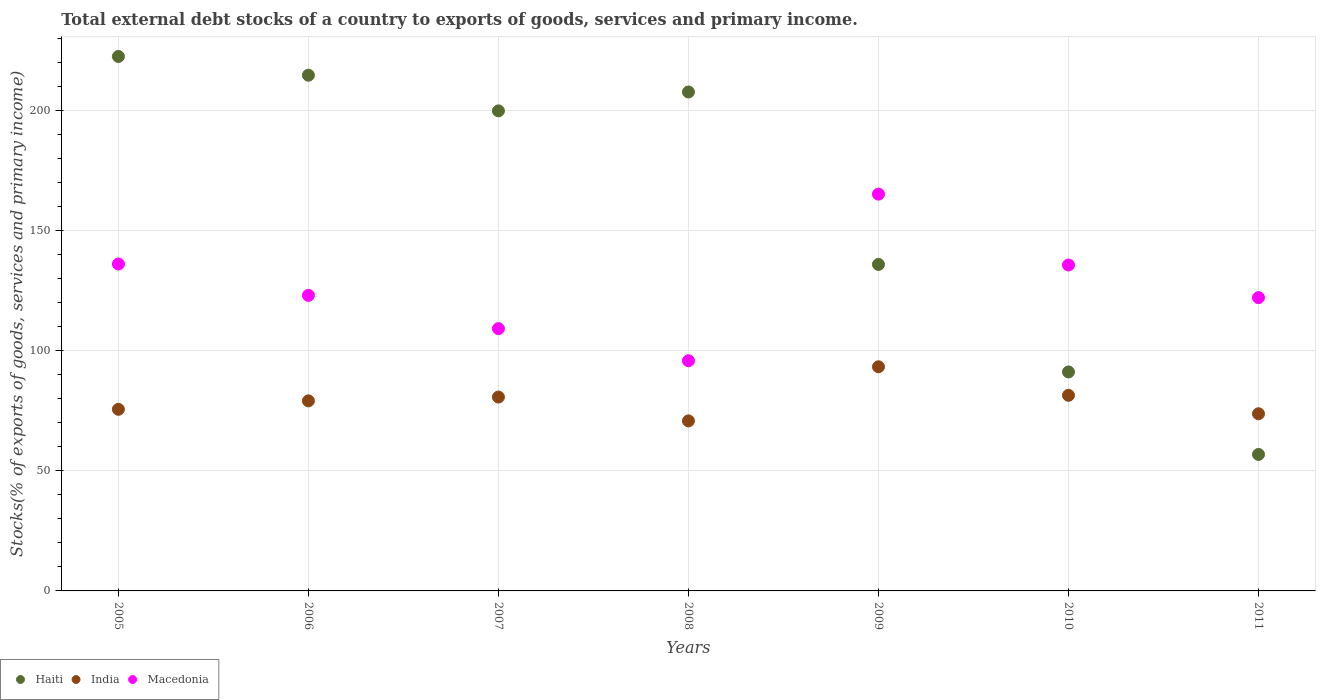What is the total debt stocks in Macedonia in 2007?
Give a very brief answer. 109.24. Across all years, what is the maximum total debt stocks in Haiti?
Ensure brevity in your answer.  222.59. Across all years, what is the minimum total debt stocks in Macedonia?
Ensure brevity in your answer.  95.87. In which year was the total debt stocks in India maximum?
Provide a short and direct response. 2009. What is the total total debt stocks in Haiti in the graph?
Your answer should be compact. 1129.14. What is the difference between the total debt stocks in Macedonia in 2005 and that in 2010?
Your answer should be compact. 0.41. What is the difference between the total debt stocks in India in 2006 and the total debt stocks in Macedonia in 2010?
Your answer should be very brief. -56.58. What is the average total debt stocks in India per year?
Give a very brief answer. 79.28. In the year 2010, what is the difference between the total debt stocks in India and total debt stocks in Macedonia?
Ensure brevity in your answer.  -54.27. In how many years, is the total debt stocks in Macedonia greater than 210 %?
Ensure brevity in your answer.  0. What is the ratio of the total debt stocks in India in 2008 to that in 2010?
Your answer should be compact. 0.87. Is the difference between the total debt stocks in India in 2005 and 2008 greater than the difference between the total debt stocks in Macedonia in 2005 and 2008?
Give a very brief answer. No. What is the difference between the highest and the second highest total debt stocks in India?
Offer a terse response. 11.88. What is the difference between the highest and the lowest total debt stocks in Haiti?
Ensure brevity in your answer.  165.74. In how many years, is the total debt stocks in Macedonia greater than the average total debt stocks in Macedonia taken over all years?
Give a very brief answer. 3. Is the sum of the total debt stocks in Haiti in 2006 and 2010 greater than the maximum total debt stocks in Macedonia across all years?
Provide a succinct answer. Yes. Is it the case that in every year, the sum of the total debt stocks in India and total debt stocks in Haiti  is greater than the total debt stocks in Macedonia?
Make the answer very short. Yes. Is the total debt stocks in Macedonia strictly greater than the total debt stocks in India over the years?
Provide a succinct answer. Yes. Is the total debt stocks in India strictly less than the total debt stocks in Haiti over the years?
Provide a short and direct response. No. Does the graph contain grids?
Your answer should be very brief. Yes. How many legend labels are there?
Your response must be concise. 3. What is the title of the graph?
Give a very brief answer. Total external debt stocks of a country to exports of goods, services and primary income. Does "Czech Republic" appear as one of the legend labels in the graph?
Provide a short and direct response. No. What is the label or title of the X-axis?
Your answer should be compact. Years. What is the label or title of the Y-axis?
Provide a succinct answer. Stocks(% of exports of goods, services and primary income). What is the Stocks(% of exports of goods, services and primary income) in Haiti in 2005?
Provide a succinct answer. 222.59. What is the Stocks(% of exports of goods, services and primary income) in India in 2005?
Offer a very short reply. 75.64. What is the Stocks(% of exports of goods, services and primary income) of Macedonia in 2005?
Offer a terse response. 136.15. What is the Stocks(% of exports of goods, services and primary income) of Haiti in 2006?
Keep it short and to the point. 214.79. What is the Stocks(% of exports of goods, services and primary income) of India in 2006?
Your answer should be very brief. 79.16. What is the Stocks(% of exports of goods, services and primary income) in Macedonia in 2006?
Provide a short and direct response. 123.09. What is the Stocks(% of exports of goods, services and primary income) in Haiti in 2007?
Your answer should be compact. 199.93. What is the Stocks(% of exports of goods, services and primary income) in India in 2007?
Make the answer very short. 80.74. What is the Stocks(% of exports of goods, services and primary income) in Macedonia in 2007?
Provide a short and direct response. 109.24. What is the Stocks(% of exports of goods, services and primary income) in Haiti in 2008?
Ensure brevity in your answer.  207.8. What is the Stocks(% of exports of goods, services and primary income) in India in 2008?
Provide a succinct answer. 70.81. What is the Stocks(% of exports of goods, services and primary income) in Macedonia in 2008?
Keep it short and to the point. 95.87. What is the Stocks(% of exports of goods, services and primary income) in Haiti in 2009?
Offer a terse response. 135.98. What is the Stocks(% of exports of goods, services and primary income) of India in 2009?
Your response must be concise. 93.35. What is the Stocks(% of exports of goods, services and primary income) of Macedonia in 2009?
Your answer should be very brief. 165.25. What is the Stocks(% of exports of goods, services and primary income) in Haiti in 2010?
Offer a terse response. 91.2. What is the Stocks(% of exports of goods, services and primary income) in India in 2010?
Keep it short and to the point. 81.47. What is the Stocks(% of exports of goods, services and primary income) of Macedonia in 2010?
Ensure brevity in your answer.  135.74. What is the Stocks(% of exports of goods, services and primary income) of Haiti in 2011?
Your answer should be very brief. 56.85. What is the Stocks(% of exports of goods, services and primary income) in India in 2011?
Keep it short and to the point. 73.79. What is the Stocks(% of exports of goods, services and primary income) in Macedonia in 2011?
Provide a succinct answer. 122.16. Across all years, what is the maximum Stocks(% of exports of goods, services and primary income) of Haiti?
Your response must be concise. 222.59. Across all years, what is the maximum Stocks(% of exports of goods, services and primary income) of India?
Offer a terse response. 93.35. Across all years, what is the maximum Stocks(% of exports of goods, services and primary income) of Macedonia?
Keep it short and to the point. 165.25. Across all years, what is the minimum Stocks(% of exports of goods, services and primary income) of Haiti?
Provide a short and direct response. 56.85. Across all years, what is the minimum Stocks(% of exports of goods, services and primary income) in India?
Provide a short and direct response. 70.81. Across all years, what is the minimum Stocks(% of exports of goods, services and primary income) in Macedonia?
Make the answer very short. 95.87. What is the total Stocks(% of exports of goods, services and primary income) of Haiti in the graph?
Ensure brevity in your answer.  1129.14. What is the total Stocks(% of exports of goods, services and primary income) in India in the graph?
Provide a succinct answer. 554.96. What is the total Stocks(% of exports of goods, services and primary income) in Macedonia in the graph?
Make the answer very short. 887.51. What is the difference between the Stocks(% of exports of goods, services and primary income) in Haiti in 2005 and that in 2006?
Give a very brief answer. 7.8. What is the difference between the Stocks(% of exports of goods, services and primary income) in India in 2005 and that in 2006?
Offer a terse response. -3.52. What is the difference between the Stocks(% of exports of goods, services and primary income) in Macedonia in 2005 and that in 2006?
Ensure brevity in your answer.  13.06. What is the difference between the Stocks(% of exports of goods, services and primary income) of Haiti in 2005 and that in 2007?
Give a very brief answer. 22.66. What is the difference between the Stocks(% of exports of goods, services and primary income) of India in 2005 and that in 2007?
Your answer should be compact. -5.1. What is the difference between the Stocks(% of exports of goods, services and primary income) in Macedonia in 2005 and that in 2007?
Make the answer very short. 26.91. What is the difference between the Stocks(% of exports of goods, services and primary income) of Haiti in 2005 and that in 2008?
Your answer should be compact. 14.79. What is the difference between the Stocks(% of exports of goods, services and primary income) in India in 2005 and that in 2008?
Provide a succinct answer. 4.82. What is the difference between the Stocks(% of exports of goods, services and primary income) in Macedonia in 2005 and that in 2008?
Make the answer very short. 40.28. What is the difference between the Stocks(% of exports of goods, services and primary income) in Haiti in 2005 and that in 2009?
Provide a short and direct response. 86.61. What is the difference between the Stocks(% of exports of goods, services and primary income) in India in 2005 and that in 2009?
Ensure brevity in your answer.  -17.71. What is the difference between the Stocks(% of exports of goods, services and primary income) in Macedonia in 2005 and that in 2009?
Make the answer very short. -29.1. What is the difference between the Stocks(% of exports of goods, services and primary income) in Haiti in 2005 and that in 2010?
Provide a succinct answer. 131.39. What is the difference between the Stocks(% of exports of goods, services and primary income) of India in 2005 and that in 2010?
Offer a terse response. -5.83. What is the difference between the Stocks(% of exports of goods, services and primary income) in Macedonia in 2005 and that in 2010?
Offer a terse response. 0.41. What is the difference between the Stocks(% of exports of goods, services and primary income) of Haiti in 2005 and that in 2011?
Keep it short and to the point. 165.74. What is the difference between the Stocks(% of exports of goods, services and primary income) of India in 2005 and that in 2011?
Make the answer very short. 1.85. What is the difference between the Stocks(% of exports of goods, services and primary income) in Macedonia in 2005 and that in 2011?
Offer a terse response. 14. What is the difference between the Stocks(% of exports of goods, services and primary income) in Haiti in 2006 and that in 2007?
Your answer should be very brief. 14.85. What is the difference between the Stocks(% of exports of goods, services and primary income) of India in 2006 and that in 2007?
Give a very brief answer. -1.58. What is the difference between the Stocks(% of exports of goods, services and primary income) of Macedonia in 2006 and that in 2007?
Your response must be concise. 13.85. What is the difference between the Stocks(% of exports of goods, services and primary income) of Haiti in 2006 and that in 2008?
Provide a succinct answer. 6.98. What is the difference between the Stocks(% of exports of goods, services and primary income) of India in 2006 and that in 2008?
Offer a terse response. 8.35. What is the difference between the Stocks(% of exports of goods, services and primary income) in Macedonia in 2006 and that in 2008?
Keep it short and to the point. 27.22. What is the difference between the Stocks(% of exports of goods, services and primary income) in Haiti in 2006 and that in 2009?
Offer a terse response. 78.81. What is the difference between the Stocks(% of exports of goods, services and primary income) of India in 2006 and that in 2009?
Give a very brief answer. -14.18. What is the difference between the Stocks(% of exports of goods, services and primary income) in Macedonia in 2006 and that in 2009?
Keep it short and to the point. -42.16. What is the difference between the Stocks(% of exports of goods, services and primary income) of Haiti in 2006 and that in 2010?
Offer a very short reply. 123.58. What is the difference between the Stocks(% of exports of goods, services and primary income) in India in 2006 and that in 2010?
Provide a succinct answer. -2.3. What is the difference between the Stocks(% of exports of goods, services and primary income) in Macedonia in 2006 and that in 2010?
Offer a very short reply. -12.65. What is the difference between the Stocks(% of exports of goods, services and primary income) of Haiti in 2006 and that in 2011?
Your response must be concise. 157.94. What is the difference between the Stocks(% of exports of goods, services and primary income) of India in 2006 and that in 2011?
Your response must be concise. 5.38. What is the difference between the Stocks(% of exports of goods, services and primary income) of Macedonia in 2006 and that in 2011?
Make the answer very short. 0.93. What is the difference between the Stocks(% of exports of goods, services and primary income) in Haiti in 2007 and that in 2008?
Your answer should be compact. -7.87. What is the difference between the Stocks(% of exports of goods, services and primary income) in India in 2007 and that in 2008?
Your response must be concise. 9.93. What is the difference between the Stocks(% of exports of goods, services and primary income) in Macedonia in 2007 and that in 2008?
Provide a short and direct response. 13.37. What is the difference between the Stocks(% of exports of goods, services and primary income) of Haiti in 2007 and that in 2009?
Provide a succinct answer. 63.96. What is the difference between the Stocks(% of exports of goods, services and primary income) of India in 2007 and that in 2009?
Offer a terse response. -12.61. What is the difference between the Stocks(% of exports of goods, services and primary income) in Macedonia in 2007 and that in 2009?
Provide a short and direct response. -56.01. What is the difference between the Stocks(% of exports of goods, services and primary income) of Haiti in 2007 and that in 2010?
Your answer should be very brief. 108.73. What is the difference between the Stocks(% of exports of goods, services and primary income) of India in 2007 and that in 2010?
Offer a very short reply. -0.73. What is the difference between the Stocks(% of exports of goods, services and primary income) of Macedonia in 2007 and that in 2010?
Provide a short and direct response. -26.5. What is the difference between the Stocks(% of exports of goods, services and primary income) in Haiti in 2007 and that in 2011?
Your answer should be very brief. 143.09. What is the difference between the Stocks(% of exports of goods, services and primary income) in India in 2007 and that in 2011?
Your response must be concise. 6.96. What is the difference between the Stocks(% of exports of goods, services and primary income) in Macedonia in 2007 and that in 2011?
Keep it short and to the point. -12.92. What is the difference between the Stocks(% of exports of goods, services and primary income) in Haiti in 2008 and that in 2009?
Keep it short and to the point. 71.83. What is the difference between the Stocks(% of exports of goods, services and primary income) in India in 2008 and that in 2009?
Your answer should be compact. -22.53. What is the difference between the Stocks(% of exports of goods, services and primary income) in Macedonia in 2008 and that in 2009?
Ensure brevity in your answer.  -69.38. What is the difference between the Stocks(% of exports of goods, services and primary income) in Haiti in 2008 and that in 2010?
Your answer should be compact. 116.6. What is the difference between the Stocks(% of exports of goods, services and primary income) of India in 2008 and that in 2010?
Your answer should be very brief. -10.65. What is the difference between the Stocks(% of exports of goods, services and primary income) of Macedonia in 2008 and that in 2010?
Offer a terse response. -39.87. What is the difference between the Stocks(% of exports of goods, services and primary income) in Haiti in 2008 and that in 2011?
Make the answer very short. 150.96. What is the difference between the Stocks(% of exports of goods, services and primary income) of India in 2008 and that in 2011?
Ensure brevity in your answer.  -2.97. What is the difference between the Stocks(% of exports of goods, services and primary income) of Macedonia in 2008 and that in 2011?
Provide a short and direct response. -26.28. What is the difference between the Stocks(% of exports of goods, services and primary income) of Haiti in 2009 and that in 2010?
Provide a short and direct response. 44.77. What is the difference between the Stocks(% of exports of goods, services and primary income) in India in 2009 and that in 2010?
Your response must be concise. 11.88. What is the difference between the Stocks(% of exports of goods, services and primary income) of Macedonia in 2009 and that in 2010?
Ensure brevity in your answer.  29.51. What is the difference between the Stocks(% of exports of goods, services and primary income) in Haiti in 2009 and that in 2011?
Your answer should be very brief. 79.13. What is the difference between the Stocks(% of exports of goods, services and primary income) of India in 2009 and that in 2011?
Give a very brief answer. 19.56. What is the difference between the Stocks(% of exports of goods, services and primary income) of Macedonia in 2009 and that in 2011?
Keep it short and to the point. 43.1. What is the difference between the Stocks(% of exports of goods, services and primary income) of Haiti in 2010 and that in 2011?
Ensure brevity in your answer.  34.35. What is the difference between the Stocks(% of exports of goods, services and primary income) of India in 2010 and that in 2011?
Your answer should be compact. 7.68. What is the difference between the Stocks(% of exports of goods, services and primary income) in Macedonia in 2010 and that in 2011?
Make the answer very short. 13.58. What is the difference between the Stocks(% of exports of goods, services and primary income) of Haiti in 2005 and the Stocks(% of exports of goods, services and primary income) of India in 2006?
Ensure brevity in your answer.  143.43. What is the difference between the Stocks(% of exports of goods, services and primary income) in Haiti in 2005 and the Stocks(% of exports of goods, services and primary income) in Macedonia in 2006?
Keep it short and to the point. 99.5. What is the difference between the Stocks(% of exports of goods, services and primary income) in India in 2005 and the Stocks(% of exports of goods, services and primary income) in Macedonia in 2006?
Keep it short and to the point. -47.45. What is the difference between the Stocks(% of exports of goods, services and primary income) of Haiti in 2005 and the Stocks(% of exports of goods, services and primary income) of India in 2007?
Offer a terse response. 141.85. What is the difference between the Stocks(% of exports of goods, services and primary income) of Haiti in 2005 and the Stocks(% of exports of goods, services and primary income) of Macedonia in 2007?
Give a very brief answer. 113.35. What is the difference between the Stocks(% of exports of goods, services and primary income) in India in 2005 and the Stocks(% of exports of goods, services and primary income) in Macedonia in 2007?
Provide a short and direct response. -33.6. What is the difference between the Stocks(% of exports of goods, services and primary income) of Haiti in 2005 and the Stocks(% of exports of goods, services and primary income) of India in 2008?
Keep it short and to the point. 151.78. What is the difference between the Stocks(% of exports of goods, services and primary income) of Haiti in 2005 and the Stocks(% of exports of goods, services and primary income) of Macedonia in 2008?
Ensure brevity in your answer.  126.72. What is the difference between the Stocks(% of exports of goods, services and primary income) in India in 2005 and the Stocks(% of exports of goods, services and primary income) in Macedonia in 2008?
Ensure brevity in your answer.  -20.24. What is the difference between the Stocks(% of exports of goods, services and primary income) in Haiti in 2005 and the Stocks(% of exports of goods, services and primary income) in India in 2009?
Give a very brief answer. 129.24. What is the difference between the Stocks(% of exports of goods, services and primary income) of Haiti in 2005 and the Stocks(% of exports of goods, services and primary income) of Macedonia in 2009?
Your answer should be very brief. 57.34. What is the difference between the Stocks(% of exports of goods, services and primary income) of India in 2005 and the Stocks(% of exports of goods, services and primary income) of Macedonia in 2009?
Offer a terse response. -89.62. What is the difference between the Stocks(% of exports of goods, services and primary income) in Haiti in 2005 and the Stocks(% of exports of goods, services and primary income) in India in 2010?
Keep it short and to the point. 141.12. What is the difference between the Stocks(% of exports of goods, services and primary income) in Haiti in 2005 and the Stocks(% of exports of goods, services and primary income) in Macedonia in 2010?
Offer a terse response. 86.85. What is the difference between the Stocks(% of exports of goods, services and primary income) of India in 2005 and the Stocks(% of exports of goods, services and primary income) of Macedonia in 2010?
Provide a succinct answer. -60.1. What is the difference between the Stocks(% of exports of goods, services and primary income) of Haiti in 2005 and the Stocks(% of exports of goods, services and primary income) of India in 2011?
Provide a succinct answer. 148.81. What is the difference between the Stocks(% of exports of goods, services and primary income) in Haiti in 2005 and the Stocks(% of exports of goods, services and primary income) in Macedonia in 2011?
Your answer should be very brief. 100.43. What is the difference between the Stocks(% of exports of goods, services and primary income) in India in 2005 and the Stocks(% of exports of goods, services and primary income) in Macedonia in 2011?
Your answer should be compact. -46.52. What is the difference between the Stocks(% of exports of goods, services and primary income) in Haiti in 2006 and the Stocks(% of exports of goods, services and primary income) in India in 2007?
Your answer should be compact. 134.05. What is the difference between the Stocks(% of exports of goods, services and primary income) in Haiti in 2006 and the Stocks(% of exports of goods, services and primary income) in Macedonia in 2007?
Your answer should be compact. 105.55. What is the difference between the Stocks(% of exports of goods, services and primary income) in India in 2006 and the Stocks(% of exports of goods, services and primary income) in Macedonia in 2007?
Your answer should be very brief. -30.08. What is the difference between the Stocks(% of exports of goods, services and primary income) in Haiti in 2006 and the Stocks(% of exports of goods, services and primary income) in India in 2008?
Keep it short and to the point. 143.97. What is the difference between the Stocks(% of exports of goods, services and primary income) of Haiti in 2006 and the Stocks(% of exports of goods, services and primary income) of Macedonia in 2008?
Provide a succinct answer. 118.91. What is the difference between the Stocks(% of exports of goods, services and primary income) of India in 2006 and the Stocks(% of exports of goods, services and primary income) of Macedonia in 2008?
Keep it short and to the point. -16.71. What is the difference between the Stocks(% of exports of goods, services and primary income) in Haiti in 2006 and the Stocks(% of exports of goods, services and primary income) in India in 2009?
Provide a short and direct response. 121.44. What is the difference between the Stocks(% of exports of goods, services and primary income) in Haiti in 2006 and the Stocks(% of exports of goods, services and primary income) in Macedonia in 2009?
Give a very brief answer. 49.53. What is the difference between the Stocks(% of exports of goods, services and primary income) in India in 2006 and the Stocks(% of exports of goods, services and primary income) in Macedonia in 2009?
Ensure brevity in your answer.  -86.09. What is the difference between the Stocks(% of exports of goods, services and primary income) in Haiti in 2006 and the Stocks(% of exports of goods, services and primary income) in India in 2010?
Your answer should be compact. 133.32. What is the difference between the Stocks(% of exports of goods, services and primary income) of Haiti in 2006 and the Stocks(% of exports of goods, services and primary income) of Macedonia in 2010?
Provide a short and direct response. 79.04. What is the difference between the Stocks(% of exports of goods, services and primary income) in India in 2006 and the Stocks(% of exports of goods, services and primary income) in Macedonia in 2010?
Make the answer very short. -56.58. What is the difference between the Stocks(% of exports of goods, services and primary income) of Haiti in 2006 and the Stocks(% of exports of goods, services and primary income) of India in 2011?
Your answer should be very brief. 141. What is the difference between the Stocks(% of exports of goods, services and primary income) of Haiti in 2006 and the Stocks(% of exports of goods, services and primary income) of Macedonia in 2011?
Your response must be concise. 92.63. What is the difference between the Stocks(% of exports of goods, services and primary income) in India in 2006 and the Stocks(% of exports of goods, services and primary income) in Macedonia in 2011?
Keep it short and to the point. -42.99. What is the difference between the Stocks(% of exports of goods, services and primary income) of Haiti in 2007 and the Stocks(% of exports of goods, services and primary income) of India in 2008?
Offer a terse response. 129.12. What is the difference between the Stocks(% of exports of goods, services and primary income) in Haiti in 2007 and the Stocks(% of exports of goods, services and primary income) in Macedonia in 2008?
Ensure brevity in your answer.  104.06. What is the difference between the Stocks(% of exports of goods, services and primary income) in India in 2007 and the Stocks(% of exports of goods, services and primary income) in Macedonia in 2008?
Your response must be concise. -15.13. What is the difference between the Stocks(% of exports of goods, services and primary income) of Haiti in 2007 and the Stocks(% of exports of goods, services and primary income) of India in 2009?
Provide a short and direct response. 106.59. What is the difference between the Stocks(% of exports of goods, services and primary income) of Haiti in 2007 and the Stocks(% of exports of goods, services and primary income) of Macedonia in 2009?
Provide a short and direct response. 34.68. What is the difference between the Stocks(% of exports of goods, services and primary income) of India in 2007 and the Stocks(% of exports of goods, services and primary income) of Macedonia in 2009?
Offer a very short reply. -84.51. What is the difference between the Stocks(% of exports of goods, services and primary income) in Haiti in 2007 and the Stocks(% of exports of goods, services and primary income) in India in 2010?
Make the answer very short. 118.47. What is the difference between the Stocks(% of exports of goods, services and primary income) in Haiti in 2007 and the Stocks(% of exports of goods, services and primary income) in Macedonia in 2010?
Ensure brevity in your answer.  64.19. What is the difference between the Stocks(% of exports of goods, services and primary income) in India in 2007 and the Stocks(% of exports of goods, services and primary income) in Macedonia in 2010?
Your answer should be very brief. -55. What is the difference between the Stocks(% of exports of goods, services and primary income) in Haiti in 2007 and the Stocks(% of exports of goods, services and primary income) in India in 2011?
Keep it short and to the point. 126.15. What is the difference between the Stocks(% of exports of goods, services and primary income) in Haiti in 2007 and the Stocks(% of exports of goods, services and primary income) in Macedonia in 2011?
Your answer should be compact. 77.78. What is the difference between the Stocks(% of exports of goods, services and primary income) of India in 2007 and the Stocks(% of exports of goods, services and primary income) of Macedonia in 2011?
Your answer should be compact. -41.42. What is the difference between the Stocks(% of exports of goods, services and primary income) of Haiti in 2008 and the Stocks(% of exports of goods, services and primary income) of India in 2009?
Your answer should be compact. 114.46. What is the difference between the Stocks(% of exports of goods, services and primary income) in Haiti in 2008 and the Stocks(% of exports of goods, services and primary income) in Macedonia in 2009?
Your answer should be very brief. 42.55. What is the difference between the Stocks(% of exports of goods, services and primary income) of India in 2008 and the Stocks(% of exports of goods, services and primary income) of Macedonia in 2009?
Provide a succinct answer. -94.44. What is the difference between the Stocks(% of exports of goods, services and primary income) in Haiti in 2008 and the Stocks(% of exports of goods, services and primary income) in India in 2010?
Your answer should be very brief. 126.34. What is the difference between the Stocks(% of exports of goods, services and primary income) in Haiti in 2008 and the Stocks(% of exports of goods, services and primary income) in Macedonia in 2010?
Provide a succinct answer. 72.06. What is the difference between the Stocks(% of exports of goods, services and primary income) in India in 2008 and the Stocks(% of exports of goods, services and primary income) in Macedonia in 2010?
Your answer should be very brief. -64.93. What is the difference between the Stocks(% of exports of goods, services and primary income) in Haiti in 2008 and the Stocks(% of exports of goods, services and primary income) in India in 2011?
Offer a very short reply. 134.02. What is the difference between the Stocks(% of exports of goods, services and primary income) of Haiti in 2008 and the Stocks(% of exports of goods, services and primary income) of Macedonia in 2011?
Your response must be concise. 85.65. What is the difference between the Stocks(% of exports of goods, services and primary income) of India in 2008 and the Stocks(% of exports of goods, services and primary income) of Macedonia in 2011?
Keep it short and to the point. -51.34. What is the difference between the Stocks(% of exports of goods, services and primary income) in Haiti in 2009 and the Stocks(% of exports of goods, services and primary income) in India in 2010?
Make the answer very short. 54.51. What is the difference between the Stocks(% of exports of goods, services and primary income) of Haiti in 2009 and the Stocks(% of exports of goods, services and primary income) of Macedonia in 2010?
Provide a succinct answer. 0.23. What is the difference between the Stocks(% of exports of goods, services and primary income) of India in 2009 and the Stocks(% of exports of goods, services and primary income) of Macedonia in 2010?
Give a very brief answer. -42.39. What is the difference between the Stocks(% of exports of goods, services and primary income) in Haiti in 2009 and the Stocks(% of exports of goods, services and primary income) in India in 2011?
Offer a terse response. 62.19. What is the difference between the Stocks(% of exports of goods, services and primary income) of Haiti in 2009 and the Stocks(% of exports of goods, services and primary income) of Macedonia in 2011?
Give a very brief answer. 13.82. What is the difference between the Stocks(% of exports of goods, services and primary income) of India in 2009 and the Stocks(% of exports of goods, services and primary income) of Macedonia in 2011?
Your answer should be very brief. -28.81. What is the difference between the Stocks(% of exports of goods, services and primary income) in Haiti in 2010 and the Stocks(% of exports of goods, services and primary income) in India in 2011?
Offer a very short reply. 17.42. What is the difference between the Stocks(% of exports of goods, services and primary income) of Haiti in 2010 and the Stocks(% of exports of goods, services and primary income) of Macedonia in 2011?
Offer a very short reply. -30.95. What is the difference between the Stocks(% of exports of goods, services and primary income) of India in 2010 and the Stocks(% of exports of goods, services and primary income) of Macedonia in 2011?
Keep it short and to the point. -40.69. What is the average Stocks(% of exports of goods, services and primary income) in Haiti per year?
Provide a succinct answer. 161.31. What is the average Stocks(% of exports of goods, services and primary income) of India per year?
Offer a terse response. 79.28. What is the average Stocks(% of exports of goods, services and primary income) of Macedonia per year?
Provide a succinct answer. 126.79. In the year 2005, what is the difference between the Stocks(% of exports of goods, services and primary income) in Haiti and Stocks(% of exports of goods, services and primary income) in India?
Make the answer very short. 146.95. In the year 2005, what is the difference between the Stocks(% of exports of goods, services and primary income) in Haiti and Stocks(% of exports of goods, services and primary income) in Macedonia?
Provide a short and direct response. 86.44. In the year 2005, what is the difference between the Stocks(% of exports of goods, services and primary income) in India and Stocks(% of exports of goods, services and primary income) in Macedonia?
Provide a succinct answer. -60.51. In the year 2006, what is the difference between the Stocks(% of exports of goods, services and primary income) in Haiti and Stocks(% of exports of goods, services and primary income) in India?
Ensure brevity in your answer.  135.62. In the year 2006, what is the difference between the Stocks(% of exports of goods, services and primary income) of Haiti and Stocks(% of exports of goods, services and primary income) of Macedonia?
Make the answer very short. 91.69. In the year 2006, what is the difference between the Stocks(% of exports of goods, services and primary income) in India and Stocks(% of exports of goods, services and primary income) in Macedonia?
Make the answer very short. -43.93. In the year 2007, what is the difference between the Stocks(% of exports of goods, services and primary income) of Haiti and Stocks(% of exports of goods, services and primary income) of India?
Your answer should be very brief. 119.19. In the year 2007, what is the difference between the Stocks(% of exports of goods, services and primary income) in Haiti and Stocks(% of exports of goods, services and primary income) in Macedonia?
Ensure brevity in your answer.  90.69. In the year 2007, what is the difference between the Stocks(% of exports of goods, services and primary income) in India and Stocks(% of exports of goods, services and primary income) in Macedonia?
Provide a short and direct response. -28.5. In the year 2008, what is the difference between the Stocks(% of exports of goods, services and primary income) of Haiti and Stocks(% of exports of goods, services and primary income) of India?
Give a very brief answer. 136.99. In the year 2008, what is the difference between the Stocks(% of exports of goods, services and primary income) of Haiti and Stocks(% of exports of goods, services and primary income) of Macedonia?
Provide a succinct answer. 111.93. In the year 2008, what is the difference between the Stocks(% of exports of goods, services and primary income) of India and Stocks(% of exports of goods, services and primary income) of Macedonia?
Provide a succinct answer. -25.06. In the year 2009, what is the difference between the Stocks(% of exports of goods, services and primary income) in Haiti and Stocks(% of exports of goods, services and primary income) in India?
Your answer should be compact. 42.63. In the year 2009, what is the difference between the Stocks(% of exports of goods, services and primary income) in Haiti and Stocks(% of exports of goods, services and primary income) in Macedonia?
Your answer should be compact. -29.28. In the year 2009, what is the difference between the Stocks(% of exports of goods, services and primary income) of India and Stocks(% of exports of goods, services and primary income) of Macedonia?
Your answer should be very brief. -71.91. In the year 2010, what is the difference between the Stocks(% of exports of goods, services and primary income) of Haiti and Stocks(% of exports of goods, services and primary income) of India?
Make the answer very short. 9.74. In the year 2010, what is the difference between the Stocks(% of exports of goods, services and primary income) in Haiti and Stocks(% of exports of goods, services and primary income) in Macedonia?
Provide a succinct answer. -44.54. In the year 2010, what is the difference between the Stocks(% of exports of goods, services and primary income) of India and Stocks(% of exports of goods, services and primary income) of Macedonia?
Your answer should be compact. -54.27. In the year 2011, what is the difference between the Stocks(% of exports of goods, services and primary income) of Haiti and Stocks(% of exports of goods, services and primary income) of India?
Offer a terse response. -16.94. In the year 2011, what is the difference between the Stocks(% of exports of goods, services and primary income) of Haiti and Stocks(% of exports of goods, services and primary income) of Macedonia?
Keep it short and to the point. -65.31. In the year 2011, what is the difference between the Stocks(% of exports of goods, services and primary income) in India and Stocks(% of exports of goods, services and primary income) in Macedonia?
Your answer should be compact. -48.37. What is the ratio of the Stocks(% of exports of goods, services and primary income) in Haiti in 2005 to that in 2006?
Give a very brief answer. 1.04. What is the ratio of the Stocks(% of exports of goods, services and primary income) of India in 2005 to that in 2006?
Ensure brevity in your answer.  0.96. What is the ratio of the Stocks(% of exports of goods, services and primary income) in Macedonia in 2005 to that in 2006?
Ensure brevity in your answer.  1.11. What is the ratio of the Stocks(% of exports of goods, services and primary income) of Haiti in 2005 to that in 2007?
Make the answer very short. 1.11. What is the ratio of the Stocks(% of exports of goods, services and primary income) of India in 2005 to that in 2007?
Give a very brief answer. 0.94. What is the ratio of the Stocks(% of exports of goods, services and primary income) of Macedonia in 2005 to that in 2007?
Your answer should be very brief. 1.25. What is the ratio of the Stocks(% of exports of goods, services and primary income) in Haiti in 2005 to that in 2008?
Provide a short and direct response. 1.07. What is the ratio of the Stocks(% of exports of goods, services and primary income) in India in 2005 to that in 2008?
Keep it short and to the point. 1.07. What is the ratio of the Stocks(% of exports of goods, services and primary income) in Macedonia in 2005 to that in 2008?
Provide a succinct answer. 1.42. What is the ratio of the Stocks(% of exports of goods, services and primary income) of Haiti in 2005 to that in 2009?
Ensure brevity in your answer.  1.64. What is the ratio of the Stocks(% of exports of goods, services and primary income) in India in 2005 to that in 2009?
Your answer should be very brief. 0.81. What is the ratio of the Stocks(% of exports of goods, services and primary income) in Macedonia in 2005 to that in 2009?
Your answer should be very brief. 0.82. What is the ratio of the Stocks(% of exports of goods, services and primary income) of Haiti in 2005 to that in 2010?
Keep it short and to the point. 2.44. What is the ratio of the Stocks(% of exports of goods, services and primary income) of India in 2005 to that in 2010?
Give a very brief answer. 0.93. What is the ratio of the Stocks(% of exports of goods, services and primary income) of Haiti in 2005 to that in 2011?
Make the answer very short. 3.92. What is the ratio of the Stocks(% of exports of goods, services and primary income) in India in 2005 to that in 2011?
Provide a succinct answer. 1.03. What is the ratio of the Stocks(% of exports of goods, services and primary income) in Macedonia in 2005 to that in 2011?
Provide a succinct answer. 1.11. What is the ratio of the Stocks(% of exports of goods, services and primary income) in Haiti in 2006 to that in 2007?
Offer a terse response. 1.07. What is the ratio of the Stocks(% of exports of goods, services and primary income) in India in 2006 to that in 2007?
Provide a succinct answer. 0.98. What is the ratio of the Stocks(% of exports of goods, services and primary income) of Macedonia in 2006 to that in 2007?
Provide a short and direct response. 1.13. What is the ratio of the Stocks(% of exports of goods, services and primary income) of Haiti in 2006 to that in 2008?
Offer a very short reply. 1.03. What is the ratio of the Stocks(% of exports of goods, services and primary income) in India in 2006 to that in 2008?
Offer a very short reply. 1.12. What is the ratio of the Stocks(% of exports of goods, services and primary income) in Macedonia in 2006 to that in 2008?
Your answer should be compact. 1.28. What is the ratio of the Stocks(% of exports of goods, services and primary income) of Haiti in 2006 to that in 2009?
Provide a short and direct response. 1.58. What is the ratio of the Stocks(% of exports of goods, services and primary income) in India in 2006 to that in 2009?
Your response must be concise. 0.85. What is the ratio of the Stocks(% of exports of goods, services and primary income) of Macedonia in 2006 to that in 2009?
Your answer should be very brief. 0.74. What is the ratio of the Stocks(% of exports of goods, services and primary income) in Haiti in 2006 to that in 2010?
Your response must be concise. 2.35. What is the ratio of the Stocks(% of exports of goods, services and primary income) in India in 2006 to that in 2010?
Provide a short and direct response. 0.97. What is the ratio of the Stocks(% of exports of goods, services and primary income) in Macedonia in 2006 to that in 2010?
Your response must be concise. 0.91. What is the ratio of the Stocks(% of exports of goods, services and primary income) in Haiti in 2006 to that in 2011?
Your response must be concise. 3.78. What is the ratio of the Stocks(% of exports of goods, services and primary income) in India in 2006 to that in 2011?
Keep it short and to the point. 1.07. What is the ratio of the Stocks(% of exports of goods, services and primary income) of Macedonia in 2006 to that in 2011?
Provide a short and direct response. 1.01. What is the ratio of the Stocks(% of exports of goods, services and primary income) of Haiti in 2007 to that in 2008?
Your answer should be very brief. 0.96. What is the ratio of the Stocks(% of exports of goods, services and primary income) of India in 2007 to that in 2008?
Keep it short and to the point. 1.14. What is the ratio of the Stocks(% of exports of goods, services and primary income) of Macedonia in 2007 to that in 2008?
Offer a very short reply. 1.14. What is the ratio of the Stocks(% of exports of goods, services and primary income) in Haiti in 2007 to that in 2009?
Provide a short and direct response. 1.47. What is the ratio of the Stocks(% of exports of goods, services and primary income) in India in 2007 to that in 2009?
Your answer should be compact. 0.86. What is the ratio of the Stocks(% of exports of goods, services and primary income) in Macedonia in 2007 to that in 2009?
Keep it short and to the point. 0.66. What is the ratio of the Stocks(% of exports of goods, services and primary income) of Haiti in 2007 to that in 2010?
Your response must be concise. 2.19. What is the ratio of the Stocks(% of exports of goods, services and primary income) of Macedonia in 2007 to that in 2010?
Provide a succinct answer. 0.8. What is the ratio of the Stocks(% of exports of goods, services and primary income) in Haiti in 2007 to that in 2011?
Offer a terse response. 3.52. What is the ratio of the Stocks(% of exports of goods, services and primary income) of India in 2007 to that in 2011?
Your answer should be very brief. 1.09. What is the ratio of the Stocks(% of exports of goods, services and primary income) in Macedonia in 2007 to that in 2011?
Provide a short and direct response. 0.89. What is the ratio of the Stocks(% of exports of goods, services and primary income) in Haiti in 2008 to that in 2009?
Offer a very short reply. 1.53. What is the ratio of the Stocks(% of exports of goods, services and primary income) of India in 2008 to that in 2009?
Your answer should be compact. 0.76. What is the ratio of the Stocks(% of exports of goods, services and primary income) in Macedonia in 2008 to that in 2009?
Offer a very short reply. 0.58. What is the ratio of the Stocks(% of exports of goods, services and primary income) of Haiti in 2008 to that in 2010?
Provide a short and direct response. 2.28. What is the ratio of the Stocks(% of exports of goods, services and primary income) of India in 2008 to that in 2010?
Ensure brevity in your answer.  0.87. What is the ratio of the Stocks(% of exports of goods, services and primary income) of Macedonia in 2008 to that in 2010?
Your answer should be very brief. 0.71. What is the ratio of the Stocks(% of exports of goods, services and primary income) in Haiti in 2008 to that in 2011?
Your response must be concise. 3.66. What is the ratio of the Stocks(% of exports of goods, services and primary income) of India in 2008 to that in 2011?
Provide a short and direct response. 0.96. What is the ratio of the Stocks(% of exports of goods, services and primary income) in Macedonia in 2008 to that in 2011?
Provide a succinct answer. 0.78. What is the ratio of the Stocks(% of exports of goods, services and primary income) in Haiti in 2009 to that in 2010?
Ensure brevity in your answer.  1.49. What is the ratio of the Stocks(% of exports of goods, services and primary income) in India in 2009 to that in 2010?
Your response must be concise. 1.15. What is the ratio of the Stocks(% of exports of goods, services and primary income) of Macedonia in 2009 to that in 2010?
Your response must be concise. 1.22. What is the ratio of the Stocks(% of exports of goods, services and primary income) in Haiti in 2009 to that in 2011?
Offer a very short reply. 2.39. What is the ratio of the Stocks(% of exports of goods, services and primary income) in India in 2009 to that in 2011?
Your answer should be very brief. 1.27. What is the ratio of the Stocks(% of exports of goods, services and primary income) of Macedonia in 2009 to that in 2011?
Make the answer very short. 1.35. What is the ratio of the Stocks(% of exports of goods, services and primary income) of Haiti in 2010 to that in 2011?
Your answer should be compact. 1.6. What is the ratio of the Stocks(% of exports of goods, services and primary income) in India in 2010 to that in 2011?
Provide a short and direct response. 1.1. What is the ratio of the Stocks(% of exports of goods, services and primary income) of Macedonia in 2010 to that in 2011?
Provide a succinct answer. 1.11. What is the difference between the highest and the second highest Stocks(% of exports of goods, services and primary income) in Haiti?
Ensure brevity in your answer.  7.8. What is the difference between the highest and the second highest Stocks(% of exports of goods, services and primary income) in India?
Provide a short and direct response. 11.88. What is the difference between the highest and the second highest Stocks(% of exports of goods, services and primary income) in Macedonia?
Your answer should be very brief. 29.1. What is the difference between the highest and the lowest Stocks(% of exports of goods, services and primary income) in Haiti?
Offer a terse response. 165.74. What is the difference between the highest and the lowest Stocks(% of exports of goods, services and primary income) in India?
Provide a short and direct response. 22.53. What is the difference between the highest and the lowest Stocks(% of exports of goods, services and primary income) in Macedonia?
Your answer should be very brief. 69.38. 